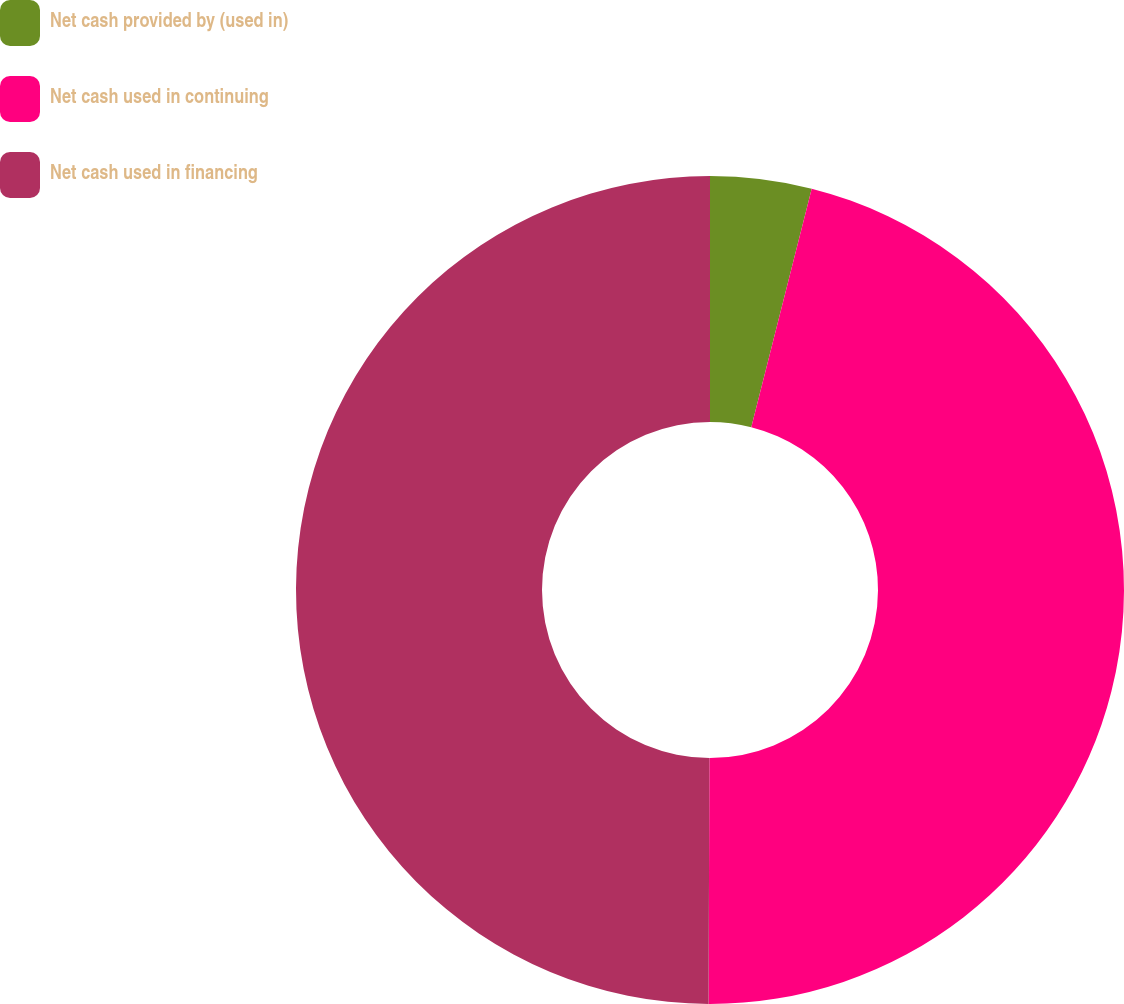Convert chart to OTSL. <chart><loc_0><loc_0><loc_500><loc_500><pie_chart><fcel>Net cash provided by (used in)<fcel>Net cash used in continuing<fcel>Net cash used in financing<nl><fcel>3.95%<fcel>46.1%<fcel>49.94%<nl></chart> 